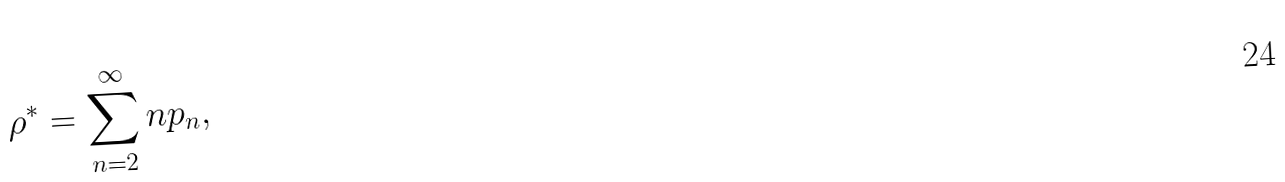Convert formula to latex. <formula><loc_0><loc_0><loc_500><loc_500>\rho ^ { * } = \sum _ { n = 2 } ^ { \infty } n p _ { n } ,</formula> 